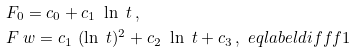<formula> <loc_0><loc_0><loc_500><loc_500>& F _ { 0 } = c _ { 0 } + c _ { 1 } \ \ln \ t \, , \\ & F _ { \ } w = c _ { 1 } \ ( \ln \ t ) ^ { 2 } + c _ { 2 } \ \ln \ t + c _ { 3 } \, , \ e q l a b e l { d i f f f 1 }</formula> 